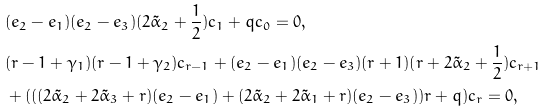Convert formula to latex. <formula><loc_0><loc_0><loc_500><loc_500>& ( e _ { 2 } - e _ { 1 } ) ( e _ { 2 } - e _ { 3 } ) ( 2 \tilde { \alpha } _ { 2 } + \frac { 1 } { 2 } ) c _ { 1 } + q c _ { 0 } = 0 , \\ & ( r - 1 + \gamma _ { 1 } ) ( r - 1 + \gamma _ { 2 } ) c _ { r - 1 } + ( e _ { 2 } - e _ { 1 } ) ( e _ { 2 } - e _ { 3 } ) ( r + 1 ) ( r + 2 \tilde { \alpha } _ { 2 } + \frac { 1 } { 2 } ) c _ { r + 1 } \\ & + ( ( ( 2 \tilde { \alpha } _ { 2 } + 2 \tilde { \alpha } _ { 3 } + r ) ( e _ { 2 } - e _ { 1 } ) + ( 2 \tilde { \alpha } _ { 2 } + 2 \tilde { \alpha } _ { 1 } + r ) ( e _ { 2 } - e _ { 3 } ) ) r + q ) c _ { r } = 0 ,</formula> 